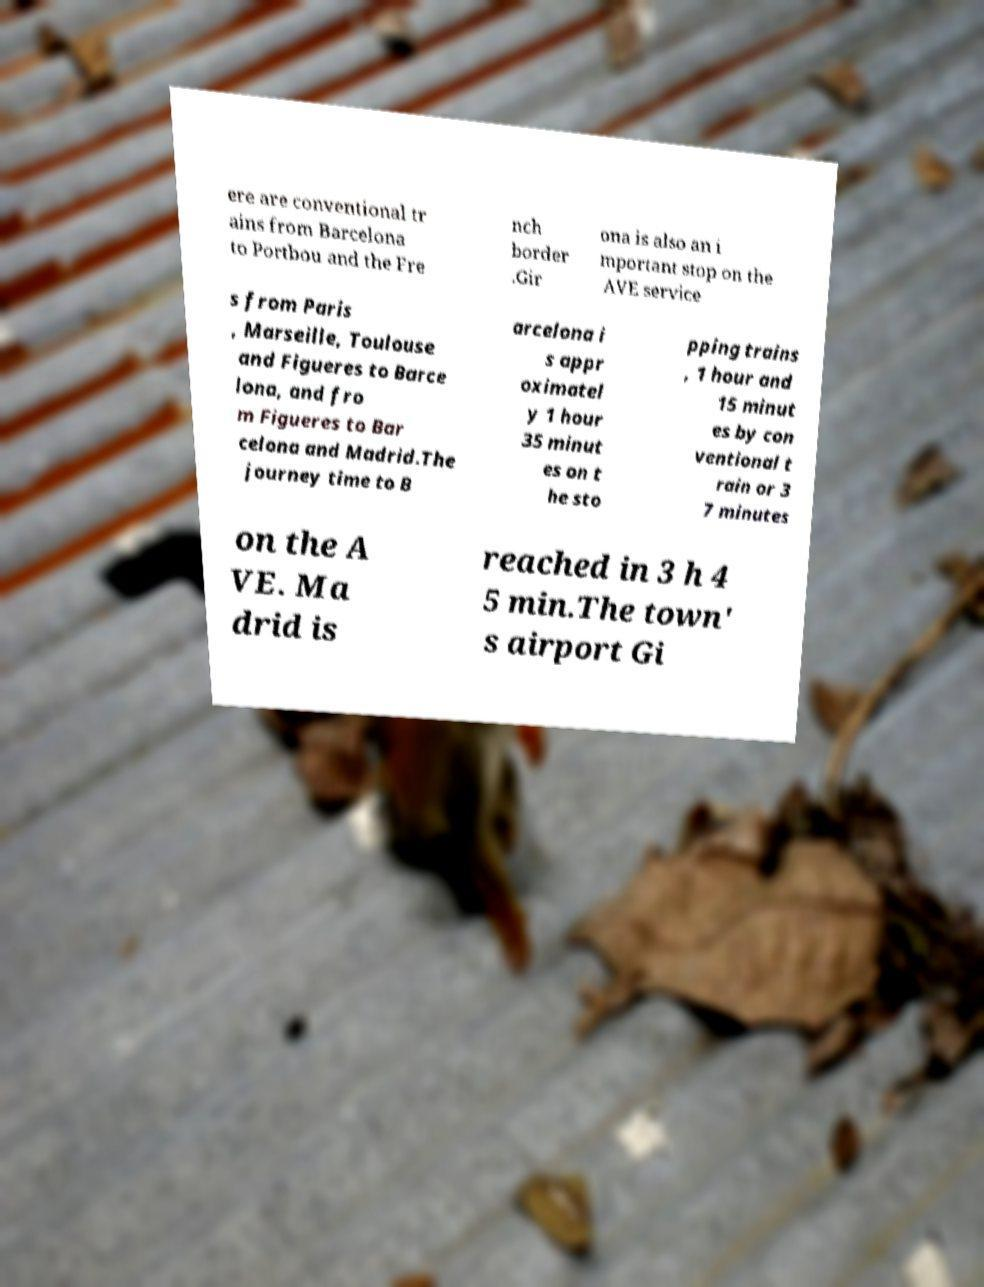Could you assist in decoding the text presented in this image and type it out clearly? ere are conventional tr ains from Barcelona to Portbou and the Fre nch border .Gir ona is also an i mportant stop on the AVE service s from Paris , Marseille, Toulouse and Figueres to Barce lona, and fro m Figueres to Bar celona and Madrid.The journey time to B arcelona i s appr oximatel y 1 hour 35 minut es on t he sto pping trains , 1 hour and 15 minut es by con ventional t rain or 3 7 minutes on the A VE. Ma drid is reached in 3 h 4 5 min.The town' s airport Gi 